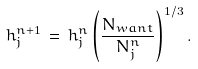Convert formula to latex. <formula><loc_0><loc_0><loc_500><loc_500>h _ { j } ^ { n + 1 } \, = \, h _ { j } ^ { n } \left ( \frac { N _ { w a n t } } { N _ { j } ^ { n } } \right ) ^ { 1 / 3 } .</formula> 